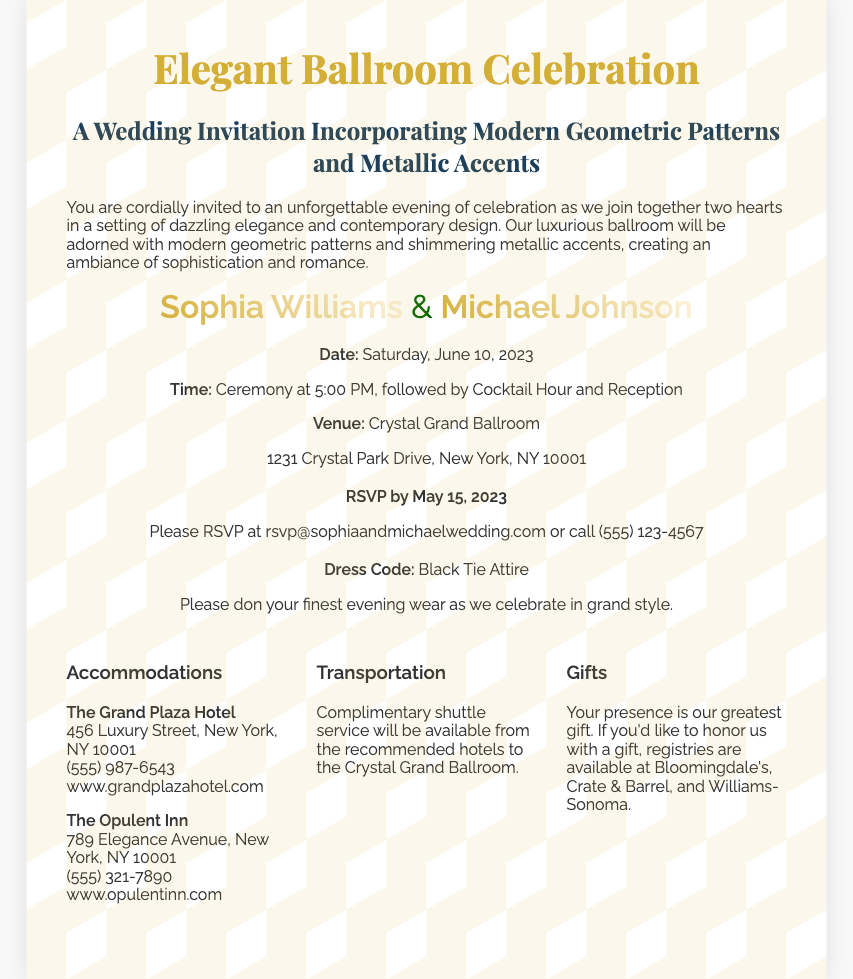What is the date of the wedding? The date of the wedding is specified in the details section of the invitation.
Answer: Saturday, June 10, 2023 What venue will the wedding be held at? The venue for the wedding is mentioned in the details section under the venue heading.
Answer: Crystal Grand Ballroom What is the RSVP deadline? The RSVP deadline is indicated in the RSVP section of the invitation.
Answer: May 15, 2023 What color scheme is used in the wedding invitation? The color scheme is described in the invitation, highlighting particular colors used.
Answer: Metallic gold and navy blue What is the dress code for the wedding? The dress code is specifically mentioned in the details section of the invitation.
Answer: Black Tie Attire Which couple is getting married? The names of the couple getting married are prominently displayed in the couple-names section.
Answer: Sophia Williams & Michael Johnson How can guests RSVP? The RSVP section provides information on how guests can respond to the invitation.
Answer: rsvp@sophiaandmichaelwedding.com or call (555) 123-4567 What type of accommodations are suggested? The additional info section includes a heading that answers this question regarding lodging options.
Answer: The Grand Plaza Hotel and The Opulent Inn What type of gifts are suggested? The gifts section indicates how the couple feels about receiving gifts and provides registry information.
Answer: Registries are available at Bloomingdale's, Crate & Barrel, and Williams-Sonoma 